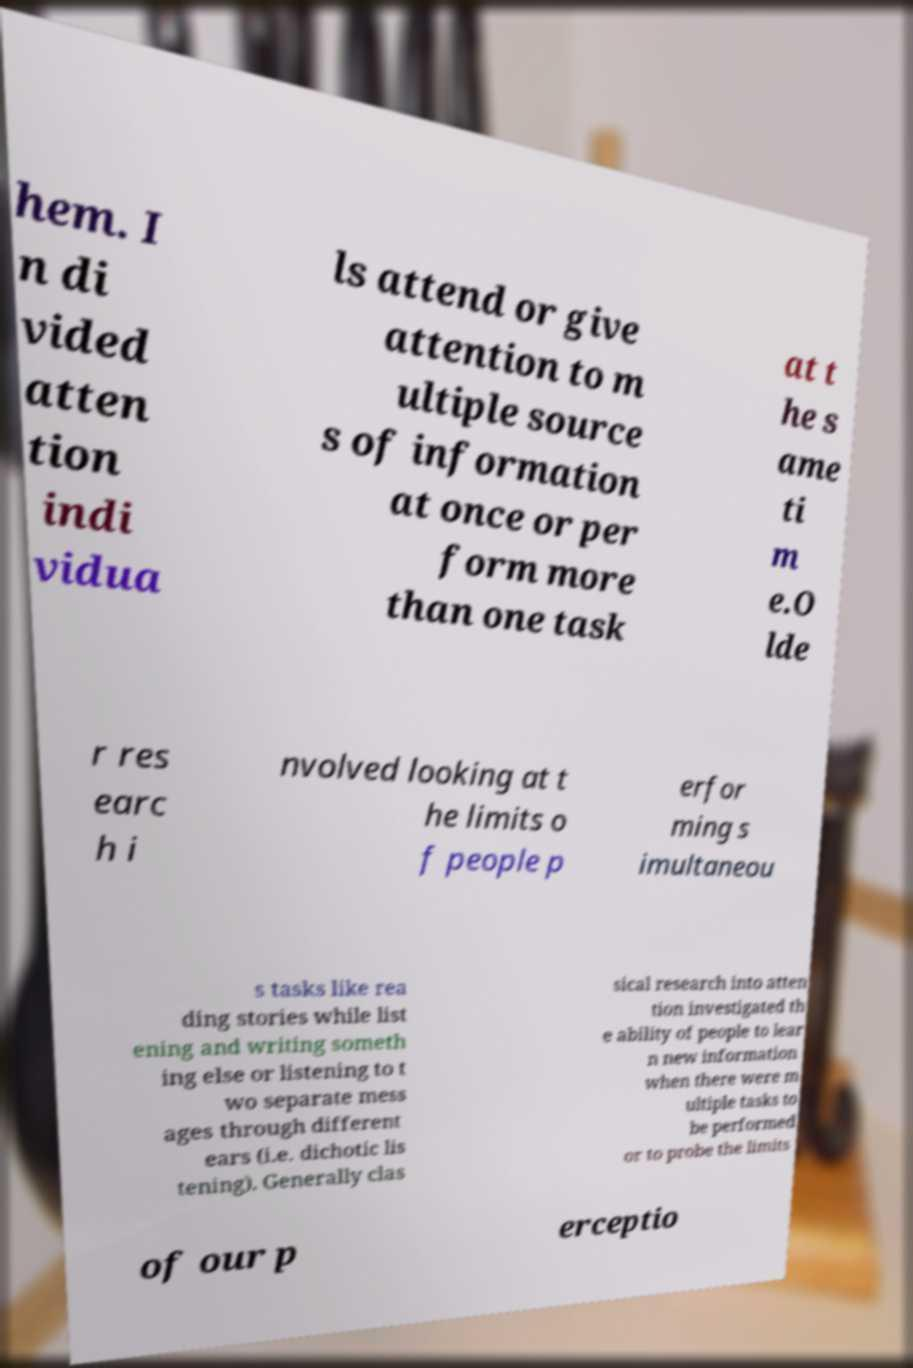Could you assist in decoding the text presented in this image and type it out clearly? hem. I n di vided atten tion indi vidua ls attend or give attention to m ultiple source s of information at once or per form more than one task at t he s ame ti m e.O lde r res earc h i nvolved looking at t he limits o f people p erfor ming s imultaneou s tasks like rea ding stories while list ening and writing someth ing else or listening to t wo separate mess ages through different ears (i.e. dichotic lis tening). Generally clas sical research into atten tion investigated th e ability of people to lear n new information when there were m ultiple tasks to be performed or to probe the limits of our p erceptio 